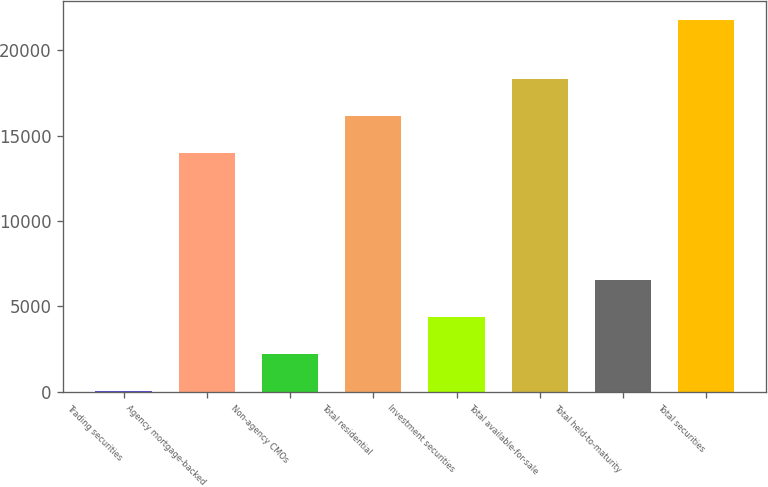Convert chart to OTSL. <chart><loc_0><loc_0><loc_500><loc_500><bar_chart><fcel>Trading securities<fcel>Agency mortgage-backed<fcel>Non-agency CMOs<fcel>Total residential<fcel>Investment securities<fcel>Total available-for-sale<fcel>Total held-to-maturity<fcel>Total securities<nl><fcel>54.4<fcel>13965.7<fcel>2227.5<fcel>16138.8<fcel>4400.6<fcel>18311.9<fcel>6573.7<fcel>21785.4<nl></chart> 